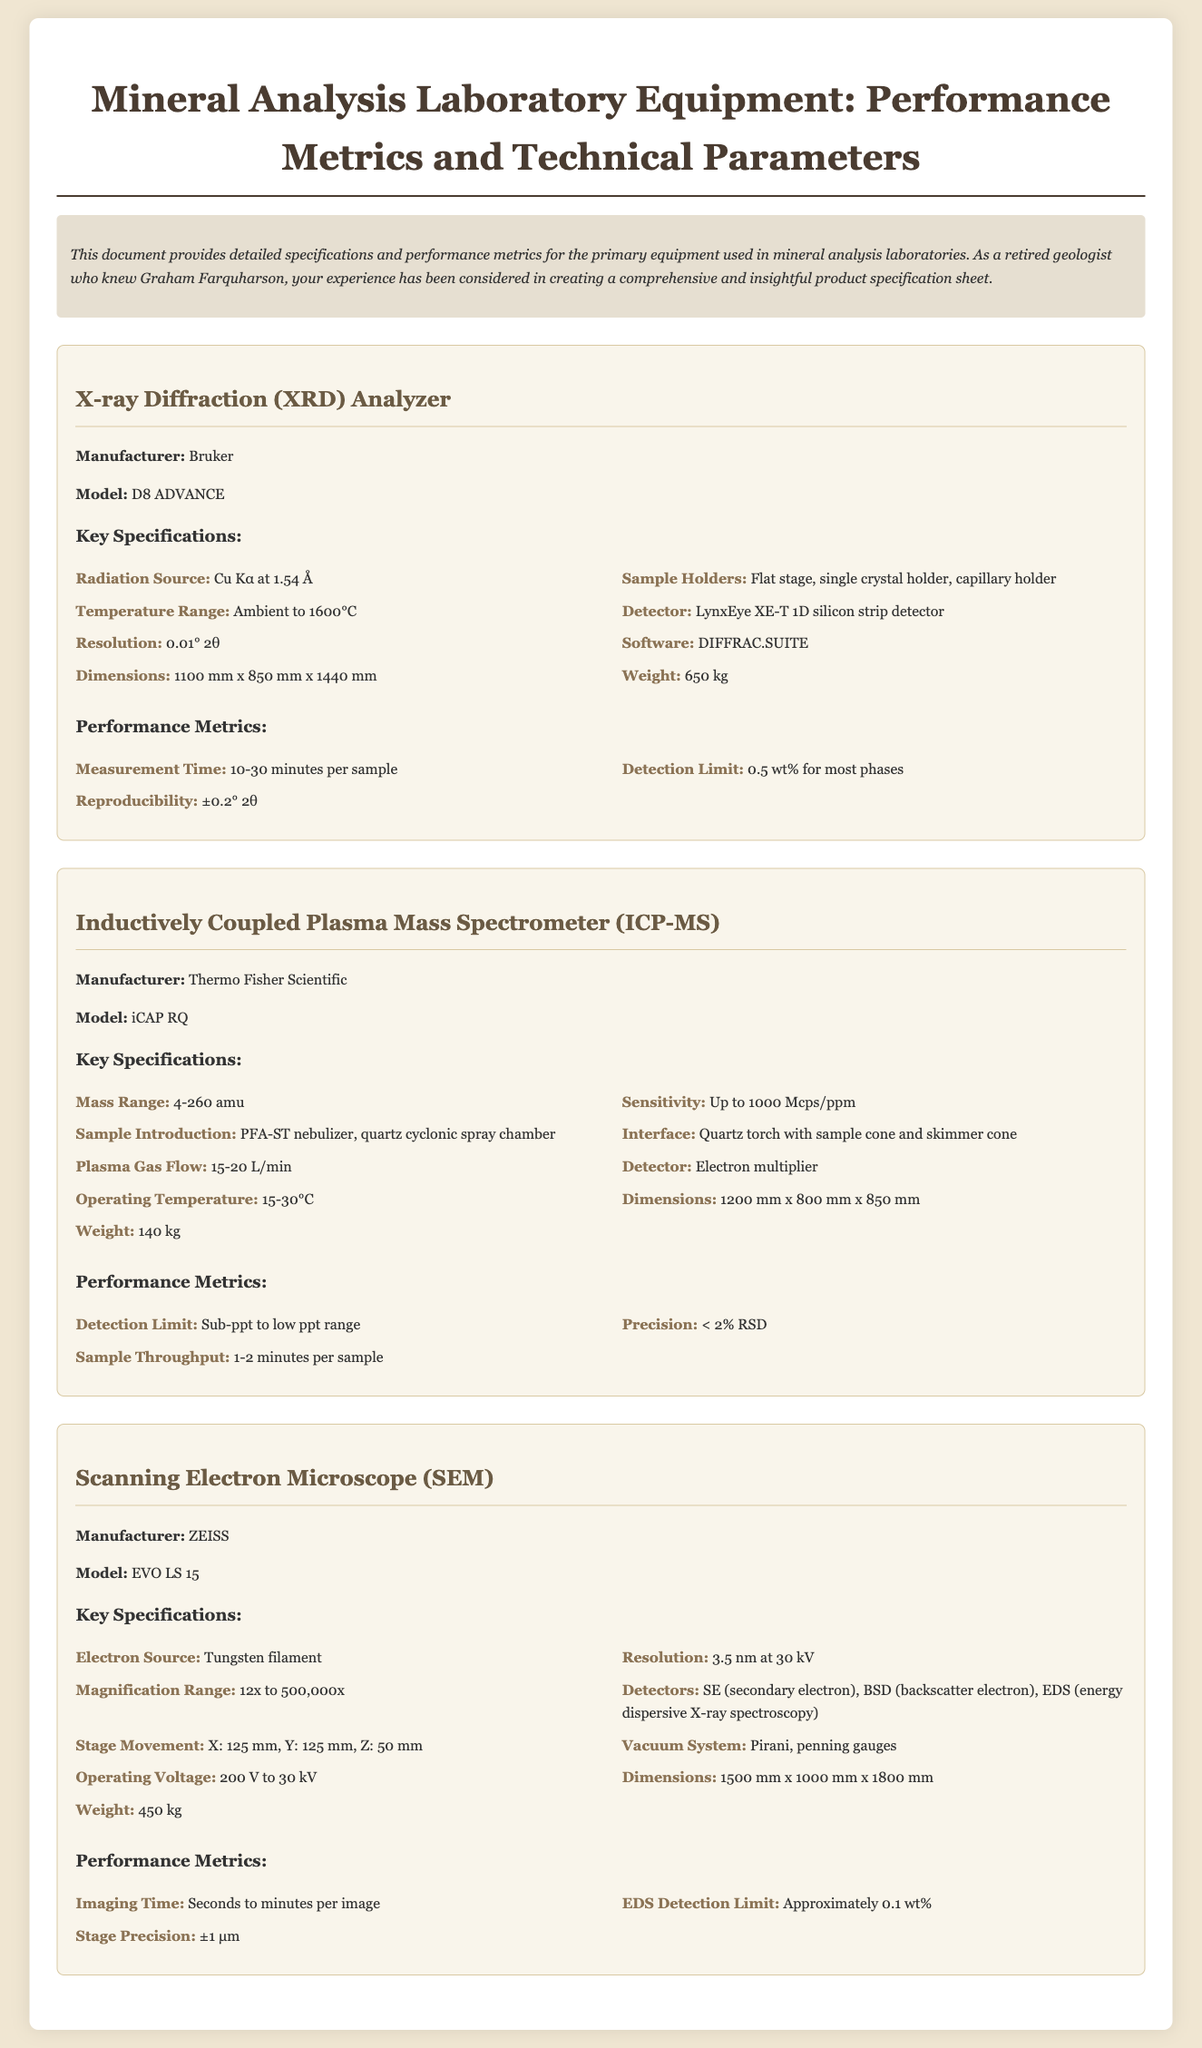What is the manufacturer of the XRD Analyzer? The manufacturer is clearly listed in the specifications for the XRD Analyzer section.
Answer: Bruker What is the model of the Scanning Electron Microscope? The model is information that can be found within the SEM equipment specifications.
Answer: EVO LS 15 What is the detection limit of the ICP-MS? The detection limit is mentioned under the performance metrics for the ICP-MS.
Answer: Sub-ppt to low ppt range What is the weight of the XRD Analyzer? The weight is specified in the key specifications for the XRD Analyzer.
Answer: 650 kg What are the dimensions of the ICP-MS? The dimensions are provided under key specifications for the ICP-MS equipment.
Answer: 1200 mm x 800 mm x 850 mm How long does it take to measure a sample with the XRD Analyzer? The measurement time for the XRD Analyzer is specified in the performance metrics section.
Answer: 10-30 minutes per sample Which detectors are used in the Scanning Electron Microscope? The detectors listed under key specifications provide the answer to the type of detectors used.
Answer: SE, BSD, EDS What is the operating temperature range of the ICP-MS? The operating temperature range is noted in the key specifications for the ICP-MS section.
Answer: 15-30°C What type of radiation source does the XRD Analyzer use? The type of radiation source is clearly stated in the key specifications of the XRD Analyzer.
Answer: Cu Kα at 1.54 Å 